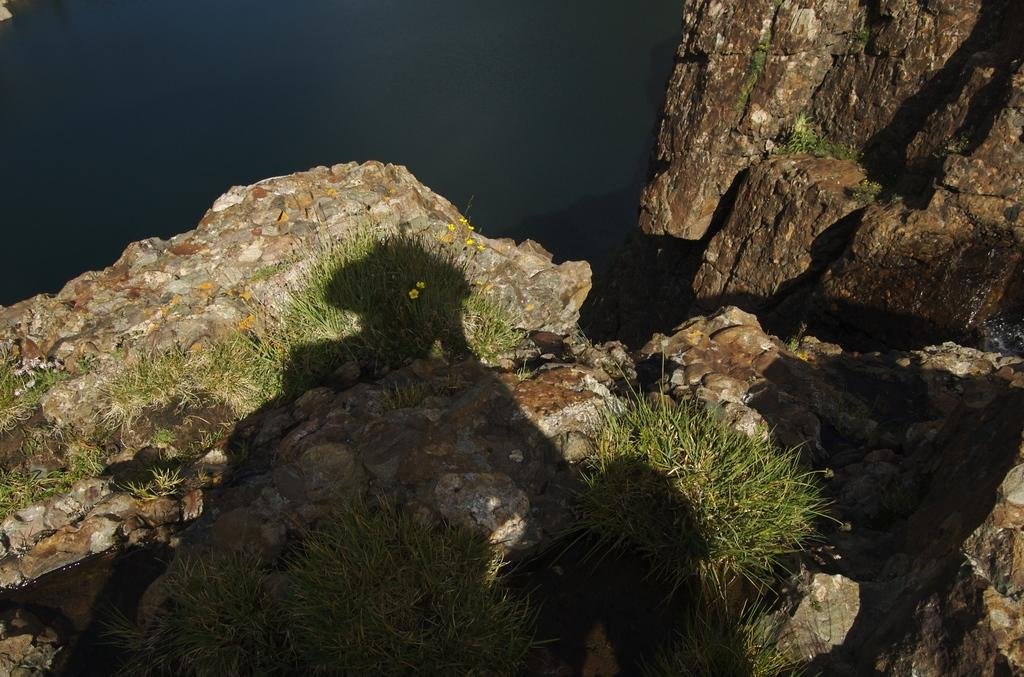What type of natural elements can be seen in the image? Rocks, grass, and water can be seen in the image. Can you describe the landscape in the image? The landscape in the image includes rocks, grass, and water. How many different types of natural elements are present in the image? There are three different types of natural elements present in the image: rocks, grass, and water. What time of day is depicted in the image? The time of day is not visible or indicated in the image. What thoughts might the rocks be having in the image? Rocks do not have thoughts, as they are inanimate objects. 